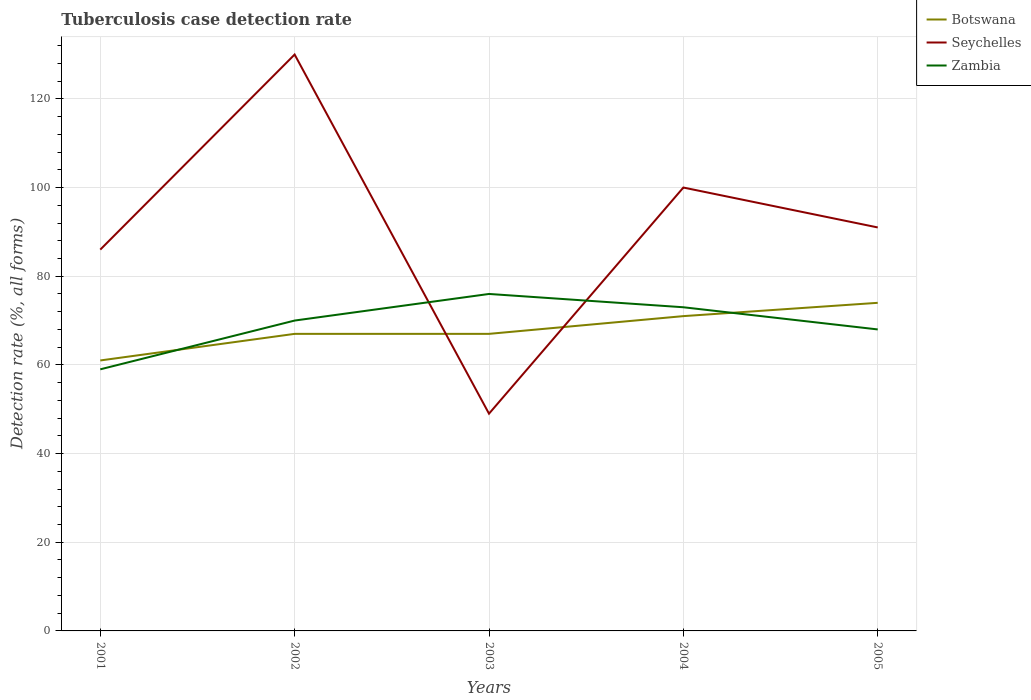Is the number of lines equal to the number of legend labels?
Keep it short and to the point. Yes. In which year was the tuberculosis case detection rate in in Zambia maximum?
Keep it short and to the point. 2001. What is the total tuberculosis case detection rate in in Botswana in the graph?
Give a very brief answer. -6. What is the difference between the highest and the second highest tuberculosis case detection rate in in Seychelles?
Offer a terse response. 81. How many lines are there?
Offer a very short reply. 3. How many years are there in the graph?
Keep it short and to the point. 5. Does the graph contain any zero values?
Your answer should be very brief. No. Does the graph contain grids?
Make the answer very short. Yes. What is the title of the graph?
Your response must be concise. Tuberculosis case detection rate. What is the label or title of the Y-axis?
Provide a succinct answer. Detection rate (%, all forms). What is the Detection rate (%, all forms) in Botswana in 2001?
Make the answer very short. 61. What is the Detection rate (%, all forms) of Zambia in 2001?
Offer a very short reply. 59. What is the Detection rate (%, all forms) of Seychelles in 2002?
Your response must be concise. 130. What is the Detection rate (%, all forms) in Botswana in 2003?
Offer a terse response. 67. What is the Detection rate (%, all forms) of Botswana in 2004?
Provide a succinct answer. 71. What is the Detection rate (%, all forms) in Seychelles in 2004?
Make the answer very short. 100. What is the Detection rate (%, all forms) of Botswana in 2005?
Your answer should be compact. 74. What is the Detection rate (%, all forms) of Seychelles in 2005?
Your answer should be very brief. 91. What is the Detection rate (%, all forms) of Zambia in 2005?
Ensure brevity in your answer.  68. Across all years, what is the maximum Detection rate (%, all forms) in Botswana?
Your answer should be compact. 74. Across all years, what is the maximum Detection rate (%, all forms) of Seychelles?
Offer a very short reply. 130. Across all years, what is the maximum Detection rate (%, all forms) in Zambia?
Your answer should be very brief. 76. What is the total Detection rate (%, all forms) in Botswana in the graph?
Ensure brevity in your answer.  340. What is the total Detection rate (%, all forms) of Seychelles in the graph?
Offer a very short reply. 456. What is the total Detection rate (%, all forms) in Zambia in the graph?
Make the answer very short. 346. What is the difference between the Detection rate (%, all forms) of Botswana in 2001 and that in 2002?
Offer a terse response. -6. What is the difference between the Detection rate (%, all forms) in Seychelles in 2001 and that in 2002?
Keep it short and to the point. -44. What is the difference between the Detection rate (%, all forms) of Botswana in 2001 and that in 2003?
Make the answer very short. -6. What is the difference between the Detection rate (%, all forms) of Seychelles in 2001 and that in 2003?
Give a very brief answer. 37. What is the difference between the Detection rate (%, all forms) in Zambia in 2001 and that in 2003?
Give a very brief answer. -17. What is the difference between the Detection rate (%, all forms) in Botswana in 2001 and that in 2004?
Provide a succinct answer. -10. What is the difference between the Detection rate (%, all forms) in Zambia in 2001 and that in 2004?
Make the answer very short. -14. What is the difference between the Detection rate (%, all forms) of Botswana in 2001 and that in 2005?
Offer a very short reply. -13. What is the difference between the Detection rate (%, all forms) of Botswana in 2002 and that in 2003?
Ensure brevity in your answer.  0. What is the difference between the Detection rate (%, all forms) in Seychelles in 2002 and that in 2003?
Make the answer very short. 81. What is the difference between the Detection rate (%, all forms) of Zambia in 2002 and that in 2003?
Keep it short and to the point. -6. What is the difference between the Detection rate (%, all forms) in Seychelles in 2002 and that in 2004?
Offer a terse response. 30. What is the difference between the Detection rate (%, all forms) of Botswana in 2002 and that in 2005?
Your answer should be compact. -7. What is the difference between the Detection rate (%, all forms) in Seychelles in 2003 and that in 2004?
Offer a very short reply. -51. What is the difference between the Detection rate (%, all forms) in Zambia in 2003 and that in 2004?
Give a very brief answer. 3. What is the difference between the Detection rate (%, all forms) of Botswana in 2003 and that in 2005?
Your answer should be very brief. -7. What is the difference between the Detection rate (%, all forms) of Seychelles in 2003 and that in 2005?
Your answer should be very brief. -42. What is the difference between the Detection rate (%, all forms) in Botswana in 2004 and that in 2005?
Provide a succinct answer. -3. What is the difference between the Detection rate (%, all forms) in Seychelles in 2004 and that in 2005?
Your answer should be very brief. 9. What is the difference between the Detection rate (%, all forms) in Botswana in 2001 and the Detection rate (%, all forms) in Seychelles in 2002?
Your answer should be very brief. -69. What is the difference between the Detection rate (%, all forms) in Botswana in 2001 and the Detection rate (%, all forms) in Zambia in 2002?
Ensure brevity in your answer.  -9. What is the difference between the Detection rate (%, all forms) in Botswana in 2001 and the Detection rate (%, all forms) in Seychelles in 2003?
Make the answer very short. 12. What is the difference between the Detection rate (%, all forms) in Botswana in 2001 and the Detection rate (%, all forms) in Zambia in 2003?
Provide a succinct answer. -15. What is the difference between the Detection rate (%, all forms) of Botswana in 2001 and the Detection rate (%, all forms) of Seychelles in 2004?
Provide a short and direct response. -39. What is the difference between the Detection rate (%, all forms) in Botswana in 2001 and the Detection rate (%, all forms) in Zambia in 2005?
Your answer should be compact. -7. What is the difference between the Detection rate (%, all forms) of Seychelles in 2001 and the Detection rate (%, all forms) of Zambia in 2005?
Keep it short and to the point. 18. What is the difference between the Detection rate (%, all forms) of Seychelles in 2002 and the Detection rate (%, all forms) of Zambia in 2003?
Ensure brevity in your answer.  54. What is the difference between the Detection rate (%, all forms) of Botswana in 2002 and the Detection rate (%, all forms) of Seychelles in 2004?
Offer a very short reply. -33. What is the difference between the Detection rate (%, all forms) of Botswana in 2002 and the Detection rate (%, all forms) of Seychelles in 2005?
Provide a succinct answer. -24. What is the difference between the Detection rate (%, all forms) in Botswana in 2003 and the Detection rate (%, all forms) in Seychelles in 2004?
Offer a very short reply. -33. What is the difference between the Detection rate (%, all forms) in Botswana in 2003 and the Detection rate (%, all forms) in Zambia in 2004?
Ensure brevity in your answer.  -6. What is the difference between the Detection rate (%, all forms) in Botswana in 2003 and the Detection rate (%, all forms) in Seychelles in 2005?
Keep it short and to the point. -24. What is the difference between the Detection rate (%, all forms) of Seychelles in 2003 and the Detection rate (%, all forms) of Zambia in 2005?
Keep it short and to the point. -19. What is the difference between the Detection rate (%, all forms) of Botswana in 2004 and the Detection rate (%, all forms) of Seychelles in 2005?
Your answer should be very brief. -20. What is the difference between the Detection rate (%, all forms) of Botswana in 2004 and the Detection rate (%, all forms) of Zambia in 2005?
Offer a very short reply. 3. What is the difference between the Detection rate (%, all forms) of Seychelles in 2004 and the Detection rate (%, all forms) of Zambia in 2005?
Offer a very short reply. 32. What is the average Detection rate (%, all forms) of Botswana per year?
Provide a succinct answer. 68. What is the average Detection rate (%, all forms) of Seychelles per year?
Offer a terse response. 91.2. What is the average Detection rate (%, all forms) in Zambia per year?
Offer a very short reply. 69.2. In the year 2001, what is the difference between the Detection rate (%, all forms) in Botswana and Detection rate (%, all forms) in Zambia?
Your response must be concise. 2. In the year 2002, what is the difference between the Detection rate (%, all forms) in Botswana and Detection rate (%, all forms) in Seychelles?
Your answer should be very brief. -63. In the year 2003, what is the difference between the Detection rate (%, all forms) in Botswana and Detection rate (%, all forms) in Zambia?
Your answer should be very brief. -9. In the year 2004, what is the difference between the Detection rate (%, all forms) in Botswana and Detection rate (%, all forms) in Zambia?
Make the answer very short. -2. In the year 2004, what is the difference between the Detection rate (%, all forms) in Seychelles and Detection rate (%, all forms) in Zambia?
Offer a terse response. 27. In the year 2005, what is the difference between the Detection rate (%, all forms) of Seychelles and Detection rate (%, all forms) of Zambia?
Offer a very short reply. 23. What is the ratio of the Detection rate (%, all forms) of Botswana in 2001 to that in 2002?
Your answer should be very brief. 0.91. What is the ratio of the Detection rate (%, all forms) in Seychelles in 2001 to that in 2002?
Offer a very short reply. 0.66. What is the ratio of the Detection rate (%, all forms) of Zambia in 2001 to that in 2002?
Give a very brief answer. 0.84. What is the ratio of the Detection rate (%, all forms) of Botswana in 2001 to that in 2003?
Your answer should be very brief. 0.91. What is the ratio of the Detection rate (%, all forms) of Seychelles in 2001 to that in 2003?
Provide a succinct answer. 1.76. What is the ratio of the Detection rate (%, all forms) of Zambia in 2001 to that in 2003?
Your answer should be compact. 0.78. What is the ratio of the Detection rate (%, all forms) of Botswana in 2001 to that in 2004?
Keep it short and to the point. 0.86. What is the ratio of the Detection rate (%, all forms) in Seychelles in 2001 to that in 2004?
Ensure brevity in your answer.  0.86. What is the ratio of the Detection rate (%, all forms) of Zambia in 2001 to that in 2004?
Ensure brevity in your answer.  0.81. What is the ratio of the Detection rate (%, all forms) of Botswana in 2001 to that in 2005?
Keep it short and to the point. 0.82. What is the ratio of the Detection rate (%, all forms) in Seychelles in 2001 to that in 2005?
Keep it short and to the point. 0.95. What is the ratio of the Detection rate (%, all forms) of Zambia in 2001 to that in 2005?
Your answer should be compact. 0.87. What is the ratio of the Detection rate (%, all forms) in Botswana in 2002 to that in 2003?
Offer a terse response. 1. What is the ratio of the Detection rate (%, all forms) of Seychelles in 2002 to that in 2003?
Provide a succinct answer. 2.65. What is the ratio of the Detection rate (%, all forms) of Zambia in 2002 to that in 2003?
Offer a terse response. 0.92. What is the ratio of the Detection rate (%, all forms) of Botswana in 2002 to that in 2004?
Your response must be concise. 0.94. What is the ratio of the Detection rate (%, all forms) in Seychelles in 2002 to that in 2004?
Your answer should be compact. 1.3. What is the ratio of the Detection rate (%, all forms) of Zambia in 2002 to that in 2004?
Your response must be concise. 0.96. What is the ratio of the Detection rate (%, all forms) in Botswana in 2002 to that in 2005?
Your answer should be very brief. 0.91. What is the ratio of the Detection rate (%, all forms) of Seychelles in 2002 to that in 2005?
Your answer should be compact. 1.43. What is the ratio of the Detection rate (%, all forms) in Zambia in 2002 to that in 2005?
Your response must be concise. 1.03. What is the ratio of the Detection rate (%, all forms) of Botswana in 2003 to that in 2004?
Ensure brevity in your answer.  0.94. What is the ratio of the Detection rate (%, all forms) of Seychelles in 2003 to that in 2004?
Your response must be concise. 0.49. What is the ratio of the Detection rate (%, all forms) of Zambia in 2003 to that in 2004?
Give a very brief answer. 1.04. What is the ratio of the Detection rate (%, all forms) of Botswana in 2003 to that in 2005?
Keep it short and to the point. 0.91. What is the ratio of the Detection rate (%, all forms) of Seychelles in 2003 to that in 2005?
Keep it short and to the point. 0.54. What is the ratio of the Detection rate (%, all forms) of Zambia in 2003 to that in 2005?
Offer a very short reply. 1.12. What is the ratio of the Detection rate (%, all forms) of Botswana in 2004 to that in 2005?
Your response must be concise. 0.96. What is the ratio of the Detection rate (%, all forms) in Seychelles in 2004 to that in 2005?
Make the answer very short. 1.1. What is the ratio of the Detection rate (%, all forms) in Zambia in 2004 to that in 2005?
Provide a succinct answer. 1.07. What is the difference between the highest and the second highest Detection rate (%, all forms) of Botswana?
Keep it short and to the point. 3. What is the difference between the highest and the second highest Detection rate (%, all forms) of Seychelles?
Your answer should be very brief. 30. What is the difference between the highest and the lowest Detection rate (%, all forms) of Seychelles?
Ensure brevity in your answer.  81. 